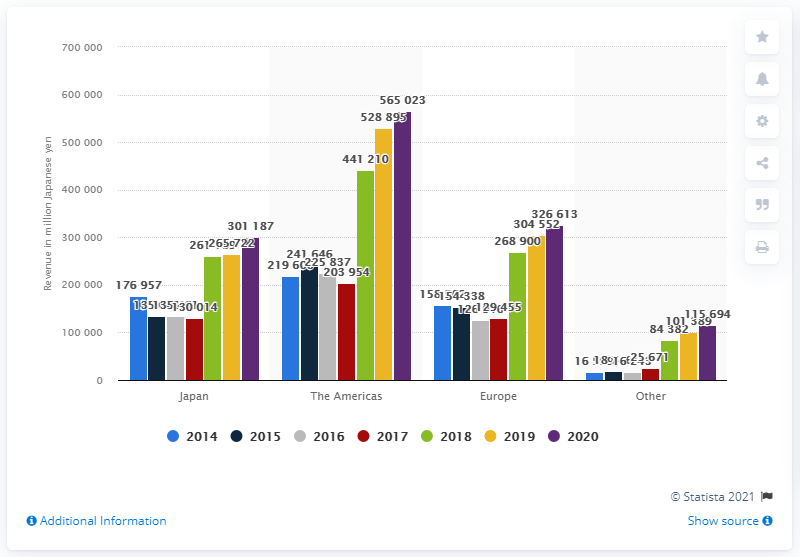Specify some key components in this picture. Nintendo generated a revenue of approximately 56,502,300 in the Americas. The second highest grossing region for Nintendo was Europe. 